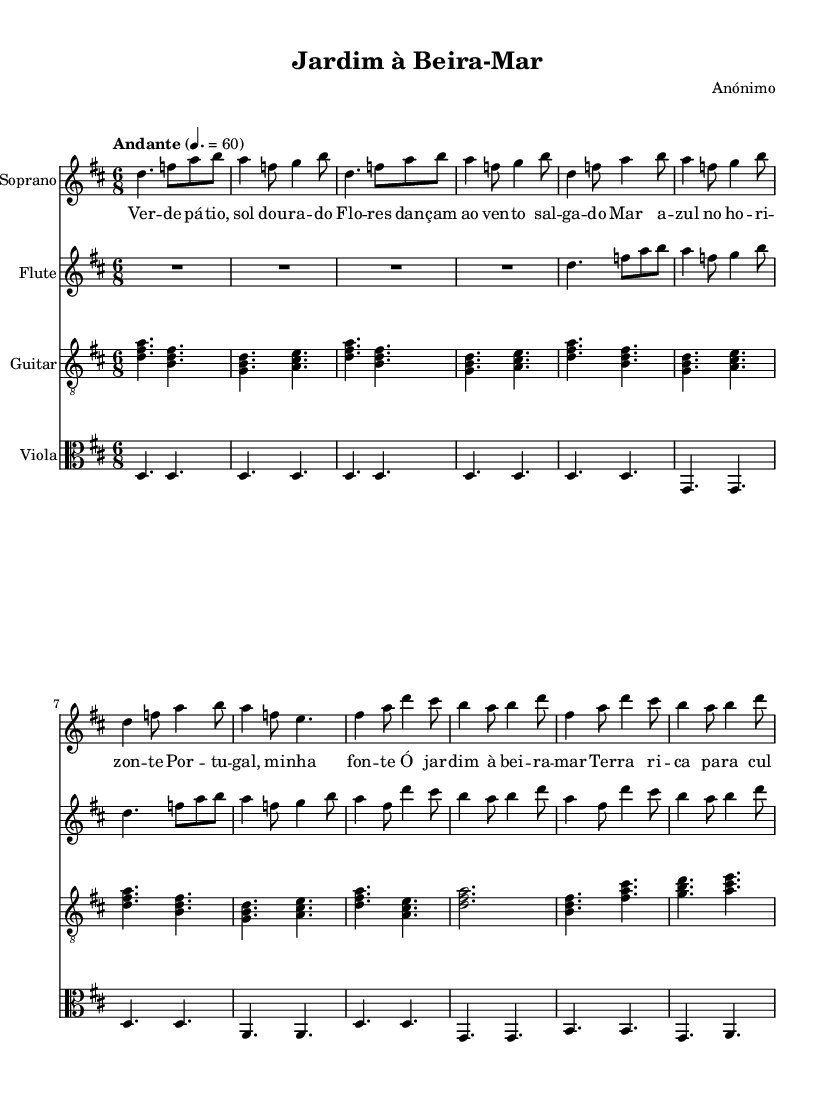What is the title of this opera? The title of the opera is "Jardim à Beira-Mar," as indicated in the header of the sheet music.
Answer: Jardim à Beira-Mar What is the key signature of the music? The key signature is D major, which contains two sharps (F# and C#), and is indicated at the beginning of the score.
Answer: D major What is the time signature of this piece? The time signature is 6/8, meaning there are six eighth notes in each measure, as shown in the first part of the score.
Answer: 6/8 What is the tempo marking found in the score? The tempo marking is "Andante," which indicates a moderate pace, and is specified at the beginning of the music.
Answer: Andante How many verses are present in the lyrics? There is one verse present in the lyrics, followed by a repeated chorus, as indicated by the structure of the lyrics in the score.
Answer: One What instruments are featured in this operatic piece? The instruments featured include Soprano, Flute, Guitar, and Viola, as listed in the score under each staff.
Answer: Soprano, Flute, Guitar, Viola What theme does the chorus celebrate? The chorus celebrates the theme of a rich garden by the sea, as indicated in the lyrics that refer to the richness of the land suitable for cultivation.
Answer: A rich garden by the sea 